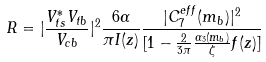<formula> <loc_0><loc_0><loc_500><loc_500>R = | { \frac { V _ { t s } ^ { \ast } V _ { t b } } { V _ { c b } } } | ^ { 2 } { \frac { 6 \alpha } { \pi I ( z ) } } { \frac { | C _ { 7 } ^ { e f f } ( m _ { b } ) | ^ { 2 } } { [ 1 - { \frac { 2 } { 3 \pi } } { \frac { \alpha _ { 3 } ( m _ { b } ) } { \zeta } } { f ( z ) ] } } }</formula> 